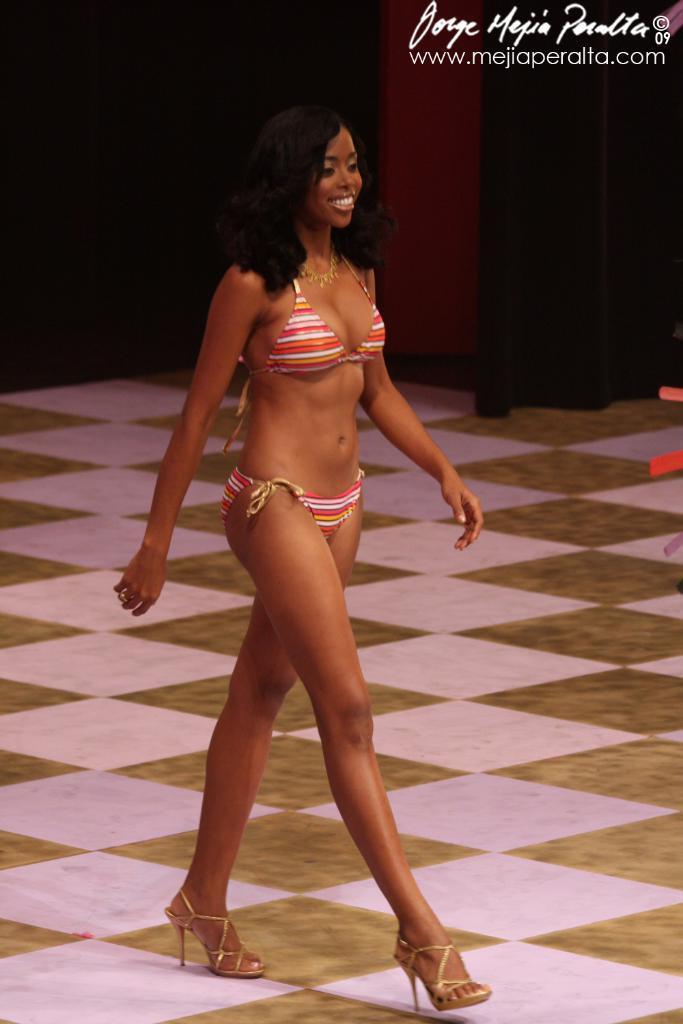How would you summarize this image in a sentence or two? In this image, we can see a person. We can see the ground and an object on the right. We can see the wall with some curtains. 